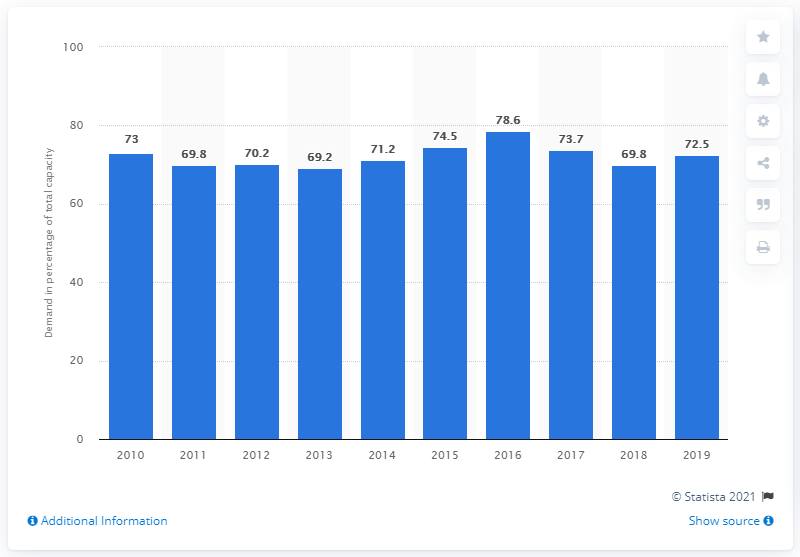Point out several critical features in this image. The maximum power demand in 2013 was 69.8.. In 2010, the maximum power demand of the UK represented approximately 72.5% of the country's total power capacity. The maximum power demand in 2013 was 69.8.. 